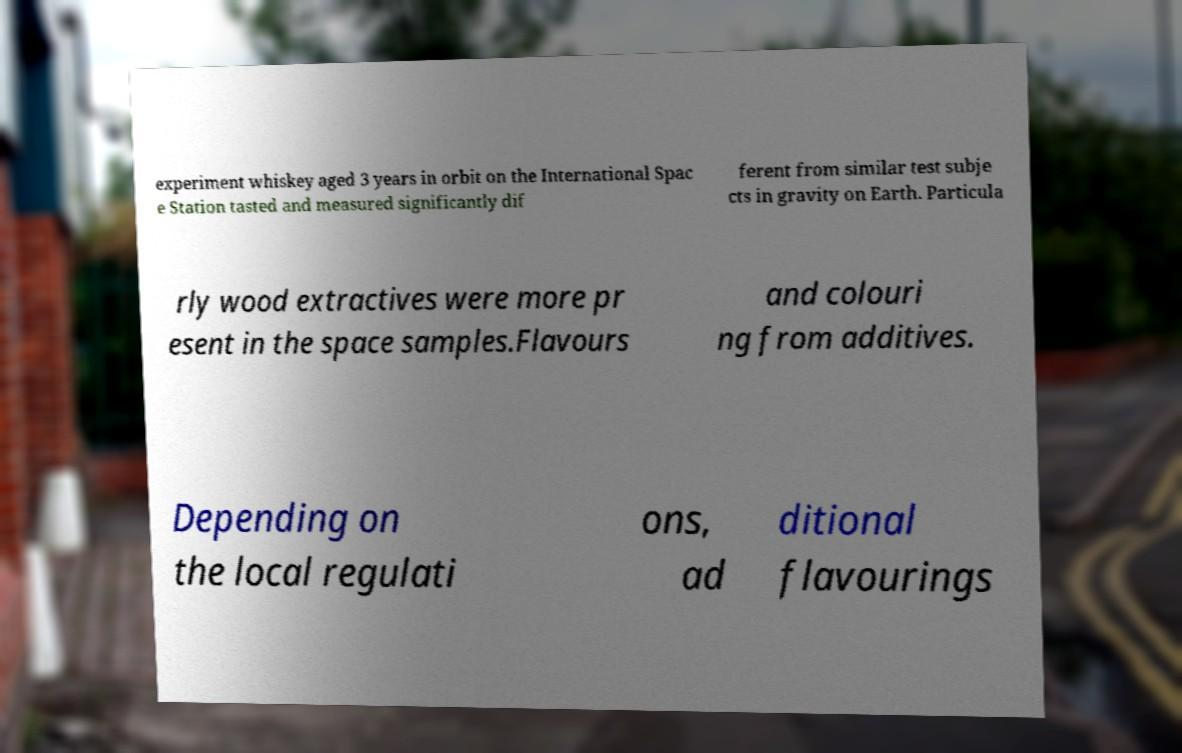Could you extract and type out the text from this image? experiment whiskey aged 3 years in orbit on the International Spac e Station tasted and measured significantly dif ferent from similar test subje cts in gravity on Earth. Particula rly wood extractives were more pr esent in the space samples.Flavours and colouri ng from additives. Depending on the local regulati ons, ad ditional flavourings 